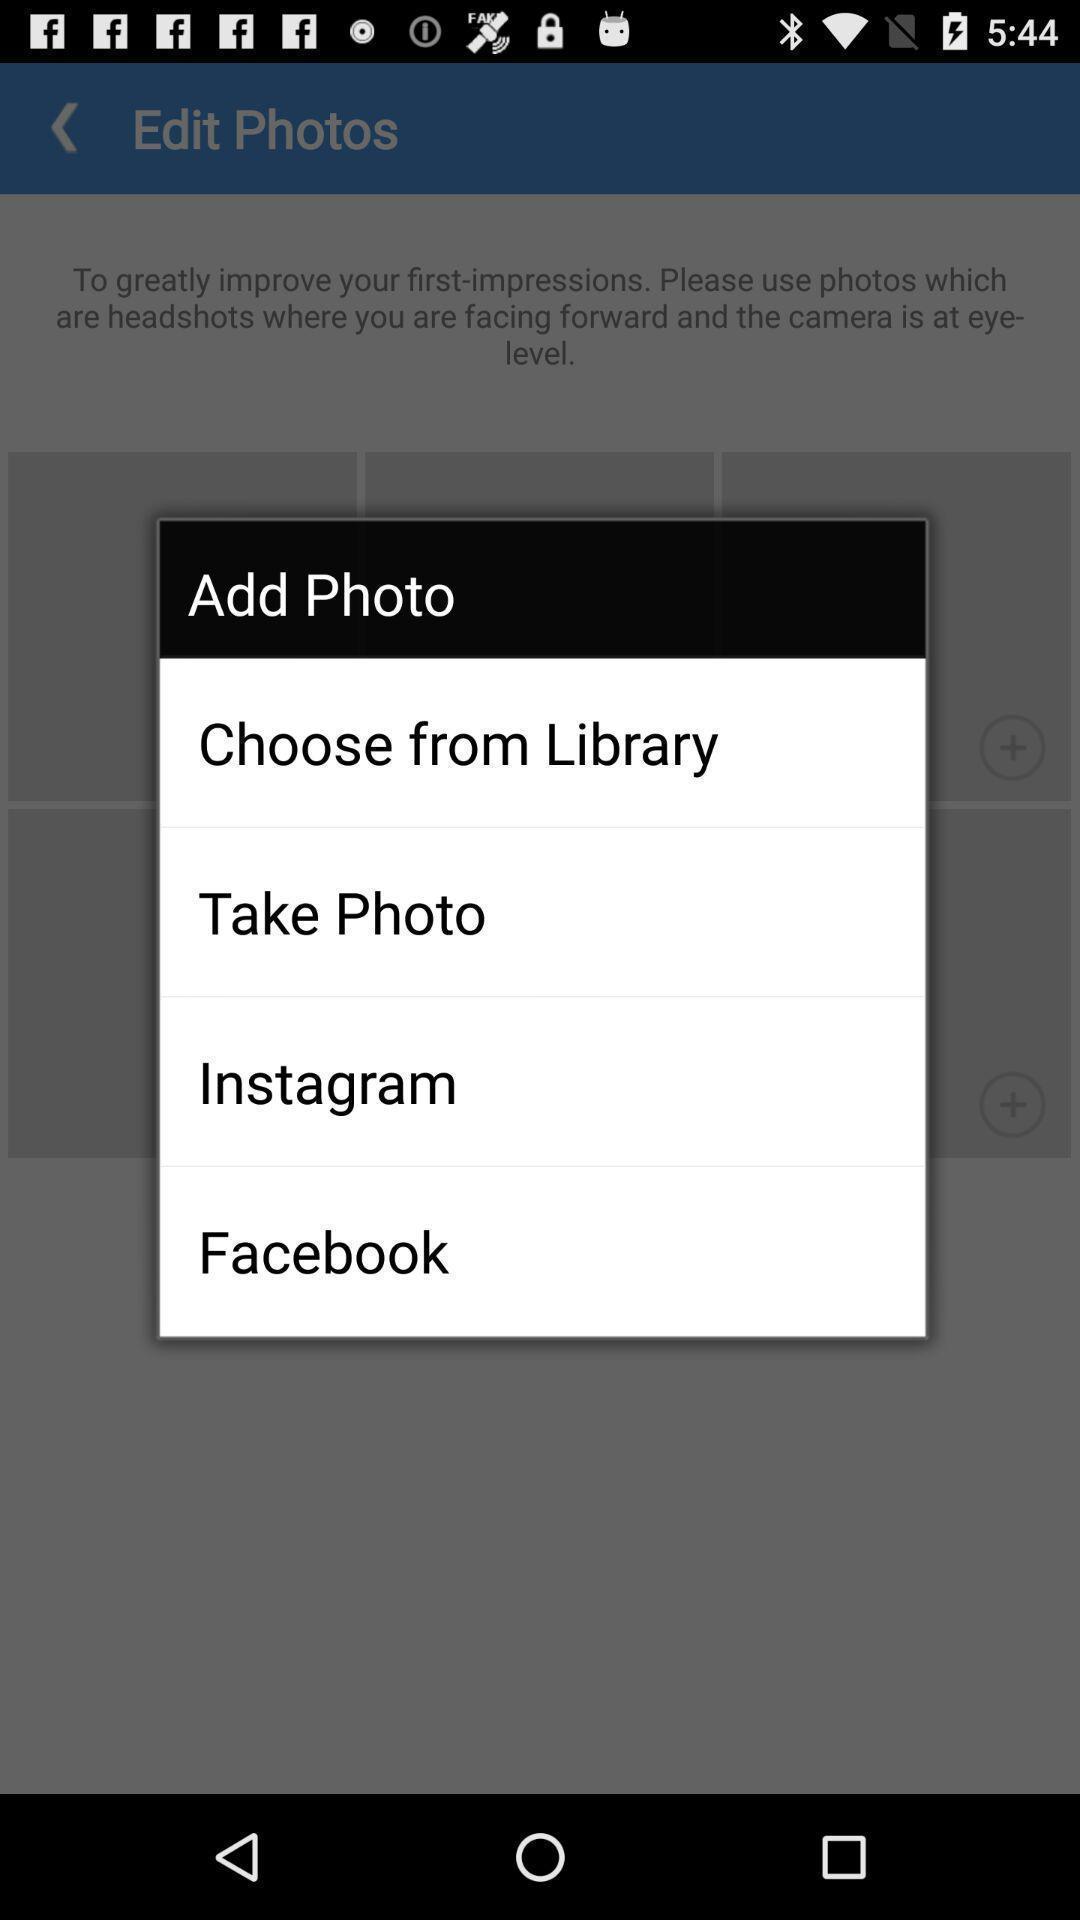Provide a description of this screenshot. Screen displaying options to add a photo. 